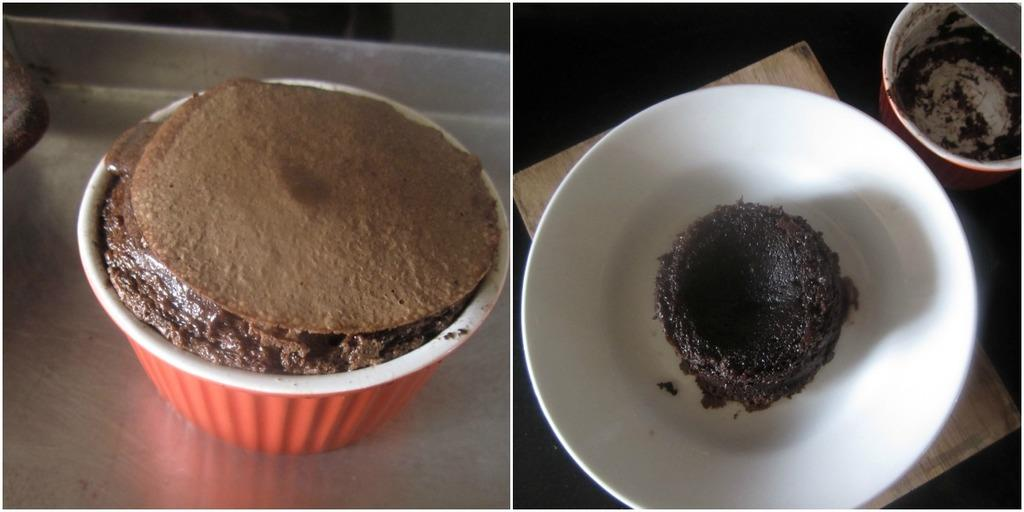What type of dishware can be seen in the image? There are cups and a bowl in the image. What type of food is visible in the image? There are cakes in the image. Can you describe any other objects in the image? There are unspecified objects in the image. What type of collar can be seen on the cake in the image? There is no collar present on the cake in the image. How does the image make you feel when you look at it? The image itself does not convey emotions, so it cannot make someone feel a certain way. 